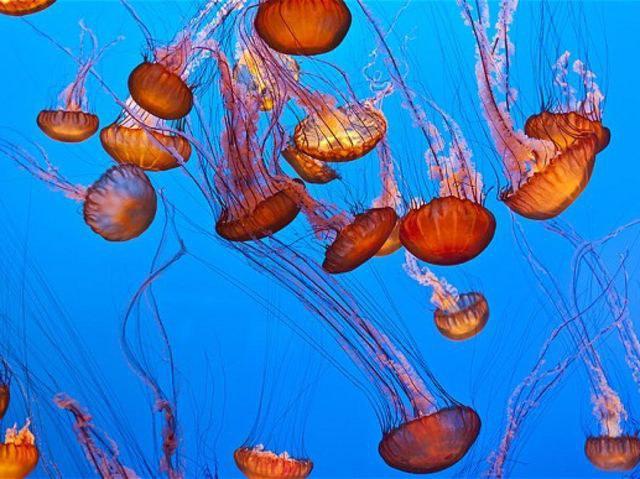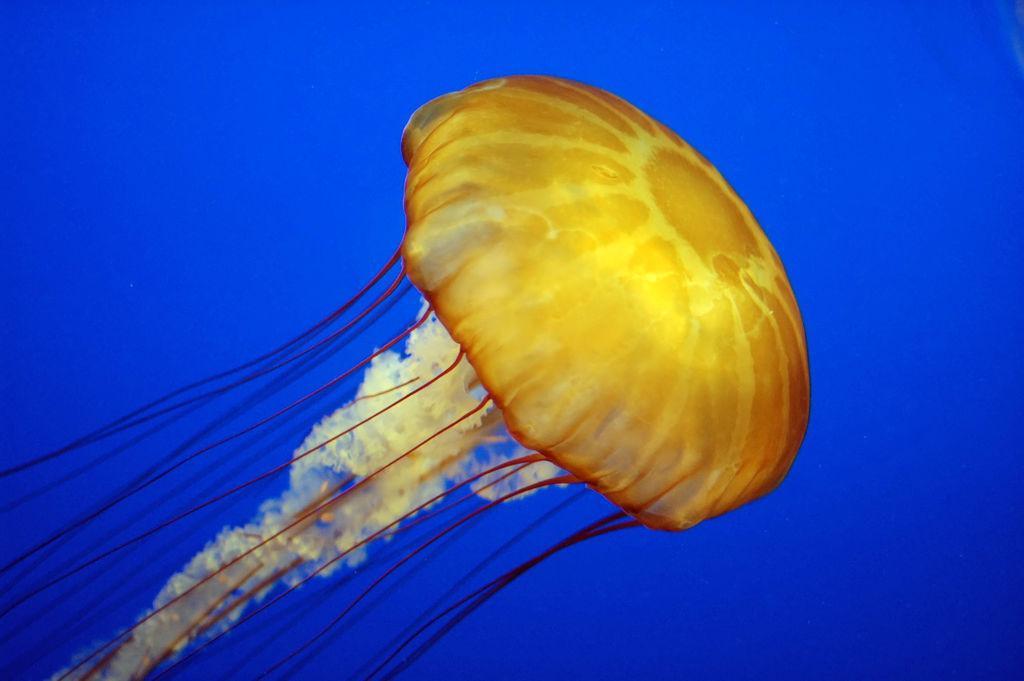The first image is the image on the left, the second image is the image on the right. For the images shown, is this caption "At least one of the jellyfish is purplish pink in color." true? Answer yes or no. No. The first image is the image on the left, the second image is the image on the right. Analyze the images presented: Is the assertion "An image shows a single jellyfish trailing something frilly and foamy looking." valid? Answer yes or no. Yes. 